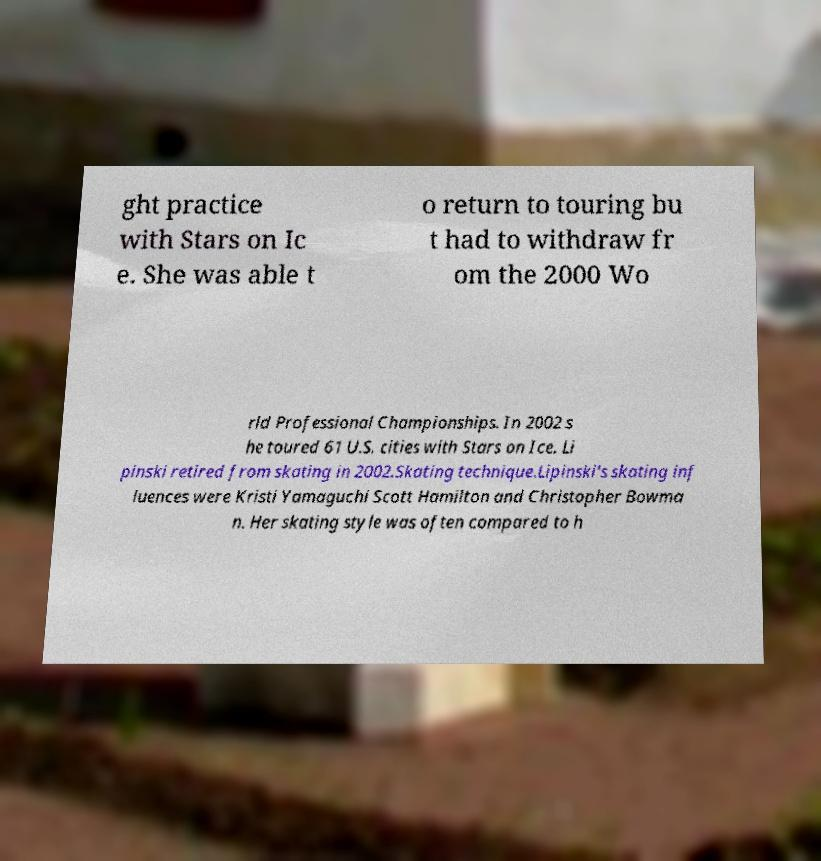I need the written content from this picture converted into text. Can you do that? ght practice with Stars on Ic e. She was able t o return to touring bu t had to withdraw fr om the 2000 Wo rld Professional Championships. In 2002 s he toured 61 U.S. cities with Stars on Ice. Li pinski retired from skating in 2002.Skating technique.Lipinski's skating inf luences were Kristi Yamaguchi Scott Hamilton and Christopher Bowma n. Her skating style was often compared to h 